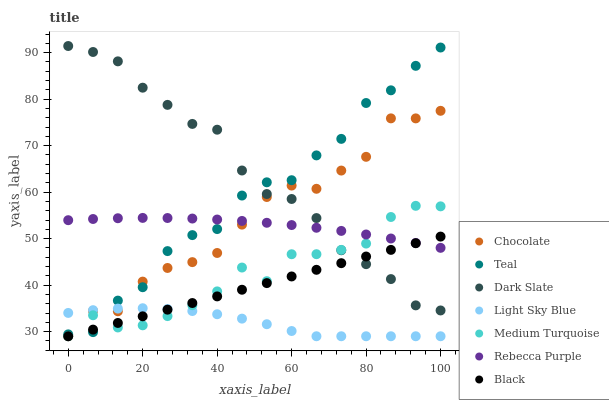Does Light Sky Blue have the minimum area under the curve?
Answer yes or no. Yes. Does Dark Slate have the maximum area under the curve?
Answer yes or no. Yes. Does Chocolate have the minimum area under the curve?
Answer yes or no. No. Does Chocolate have the maximum area under the curve?
Answer yes or no. No. Is Black the smoothest?
Answer yes or no. Yes. Is Teal the roughest?
Answer yes or no. Yes. Is Chocolate the smoothest?
Answer yes or no. No. Is Chocolate the roughest?
Answer yes or no. No. Does Chocolate have the lowest value?
Answer yes or no. Yes. Does Dark Slate have the lowest value?
Answer yes or no. No. Does Dark Slate have the highest value?
Answer yes or no. Yes. Does Chocolate have the highest value?
Answer yes or no. No. Is Light Sky Blue less than Rebecca Purple?
Answer yes or no. Yes. Is Dark Slate greater than Light Sky Blue?
Answer yes or no. Yes. Does Dark Slate intersect Medium Turquoise?
Answer yes or no. Yes. Is Dark Slate less than Medium Turquoise?
Answer yes or no. No. Is Dark Slate greater than Medium Turquoise?
Answer yes or no. No. Does Light Sky Blue intersect Rebecca Purple?
Answer yes or no. No. 